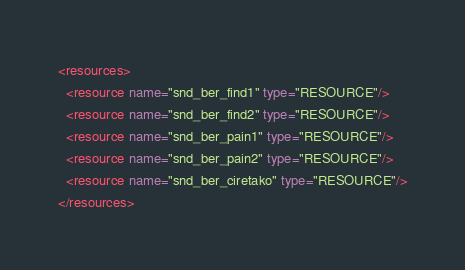Convert code to text. <code><loc_0><loc_0><loc_500><loc_500><_XML_><resources>
  <resource name="snd_ber_find1" type="RESOURCE"/>
  <resource name="snd_ber_find2" type="RESOURCE"/>
  <resource name="snd_ber_pain1" type="RESOURCE"/>
  <resource name="snd_ber_pain2" type="RESOURCE"/>
  <resource name="snd_ber_ciretako" type="RESOURCE"/>
</resources>
</code> 